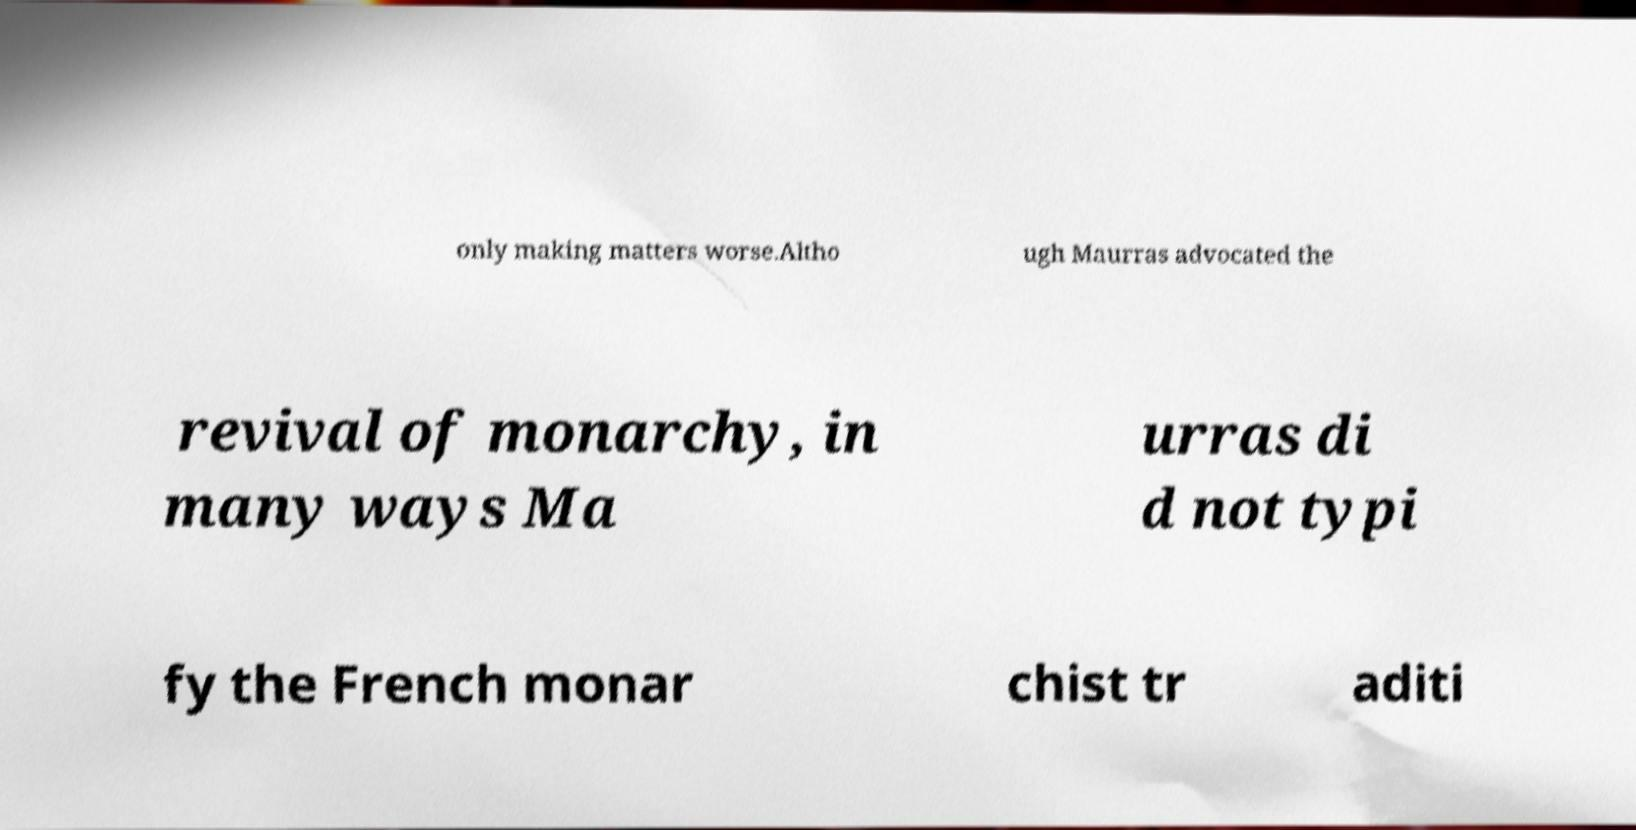Can you accurately transcribe the text from the provided image for me? only making matters worse.Altho ugh Maurras advocated the revival of monarchy, in many ways Ma urras di d not typi fy the French monar chist tr aditi 